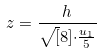Convert formula to latex. <formula><loc_0><loc_0><loc_500><loc_500>z = \frac { h } { \sqrt { [ } 8 ] { \cdot \frac { u _ { 1 } } { 5 } } }</formula> 